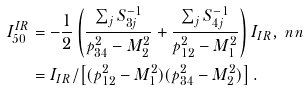Convert formula to latex. <formula><loc_0><loc_0><loc_500><loc_500>I _ { 5 0 } ^ { I R } & = - \frac { 1 } { 2 } \left ( \frac { \sum _ { j } S _ { 3 j } ^ { - 1 } } { p _ { 3 4 } ^ { 2 } - M _ { 2 } ^ { 2 } } + \frac { \sum _ { j } S _ { 4 j } ^ { - 1 } } { p _ { 1 2 } ^ { 2 } - M _ { 1 } ^ { 2 } } \right ) I _ { I R } , \ n n \\ & = I _ { I R } / \left [ ( p _ { 1 2 } ^ { 2 } - M _ { 1 } ^ { 2 } ) ( p _ { 3 4 } ^ { 2 } - M _ { 2 } ^ { 2 } ) \right ] .</formula> 